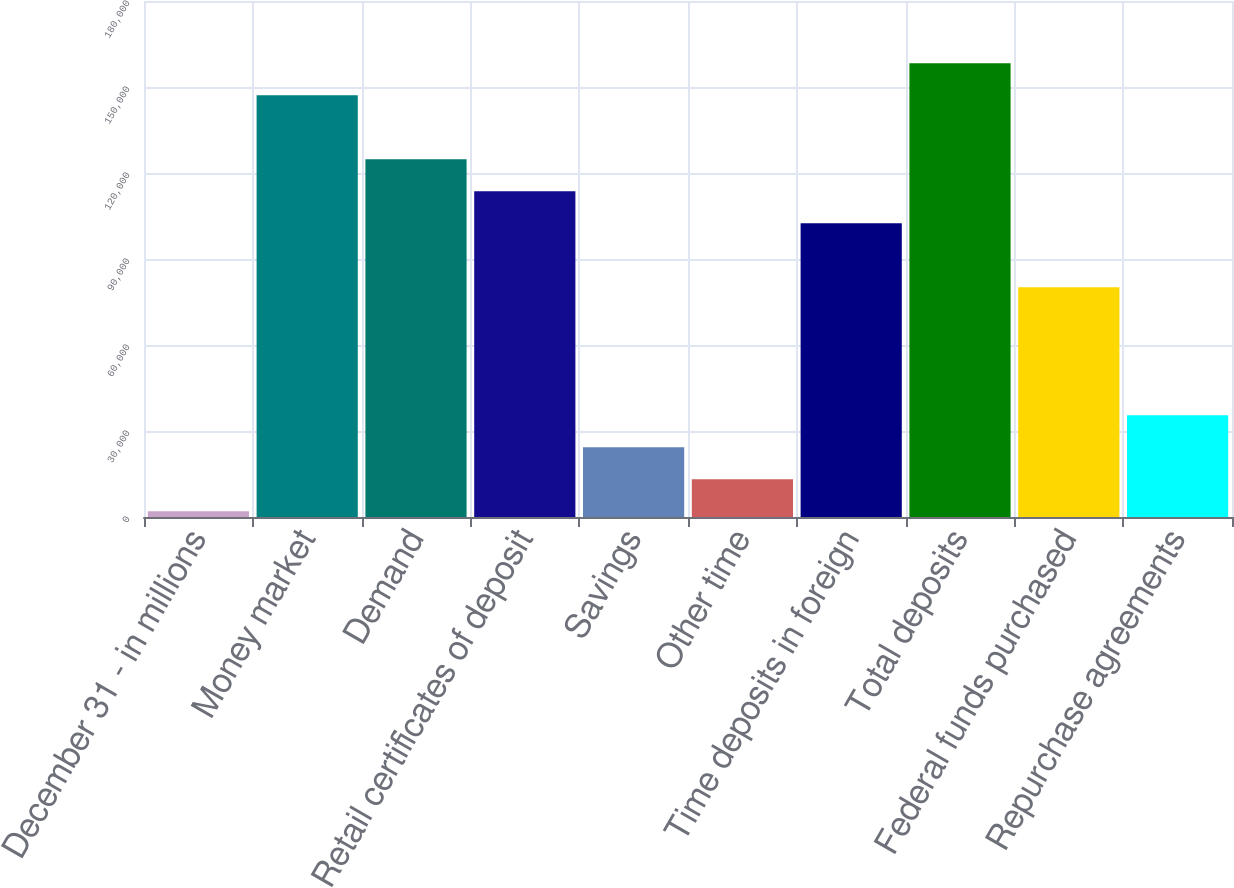Convert chart to OTSL. <chart><loc_0><loc_0><loc_500><loc_500><bar_chart><fcel>December 31 - in millions<fcel>Money market<fcel>Demand<fcel>Retail certificates of deposit<fcel>Savings<fcel>Other time<fcel>Time deposits in foreign<fcel>Total deposits<fcel>Federal funds purchased<fcel>Repurchase agreements<nl><fcel>2007<fcel>147113<fcel>124789<fcel>113627<fcel>24331<fcel>13169<fcel>102465<fcel>158275<fcel>80141<fcel>35493<nl></chart> 